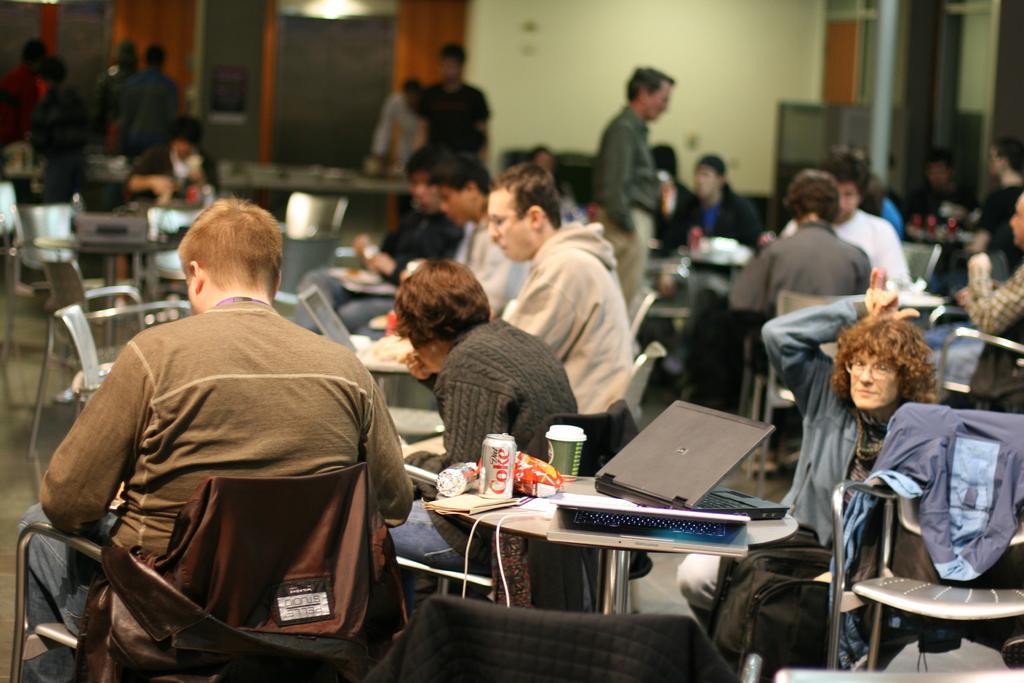Can you describe this image briefly? In this image we can see many people sitting on the chairs near the table. There are laptops, tins, cups and some food items on the table. 